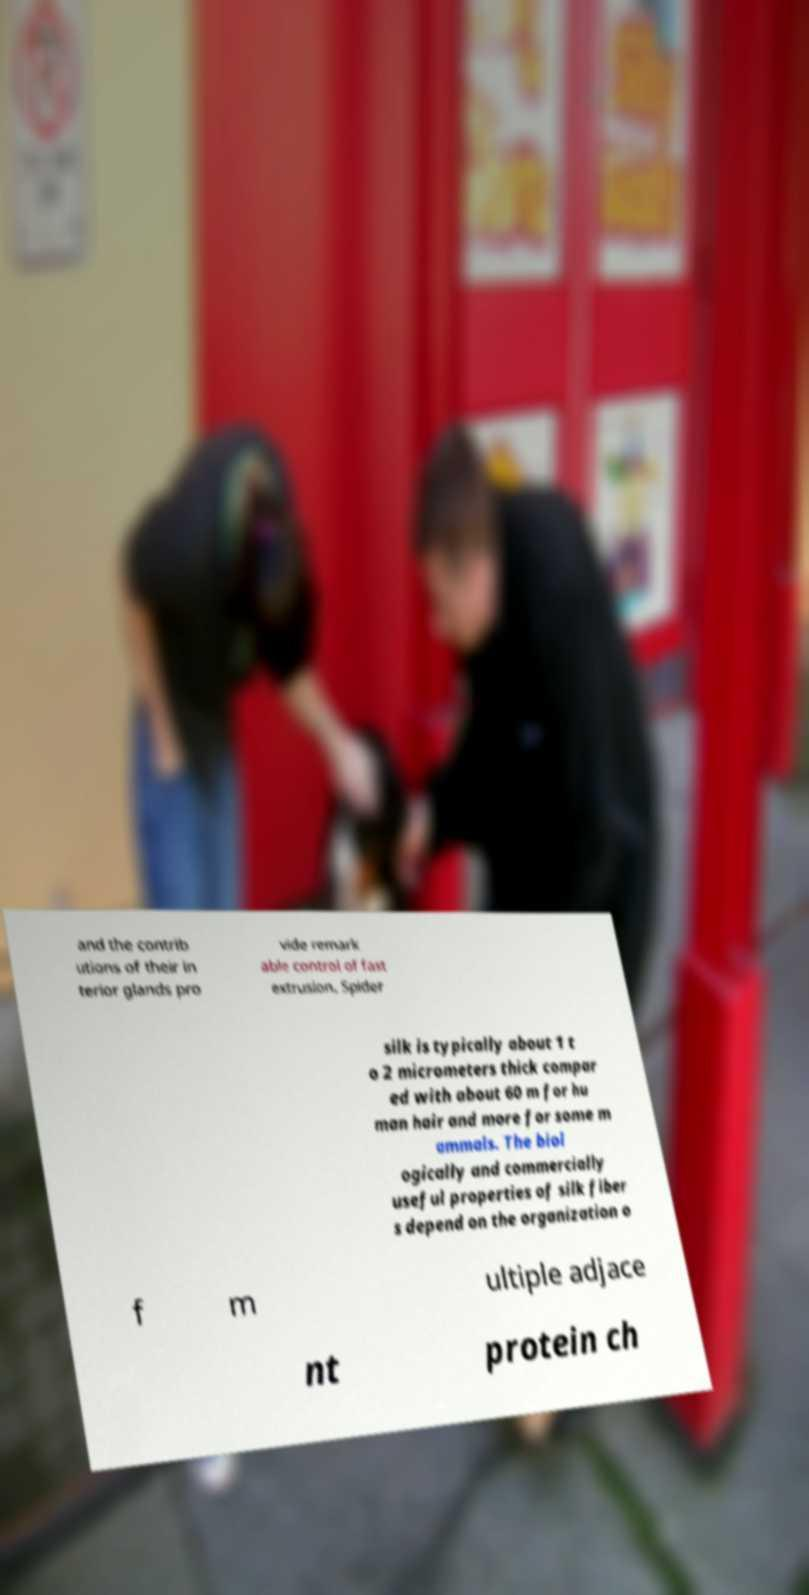Please read and relay the text visible in this image. What does it say? and the contrib utions of their in terior glands pro vide remark able control of fast extrusion. Spider silk is typically about 1 t o 2 micrometers thick compar ed with about 60 m for hu man hair and more for some m ammals. The biol ogically and commercially useful properties of silk fiber s depend on the organization o f m ultiple adjace nt protein ch 